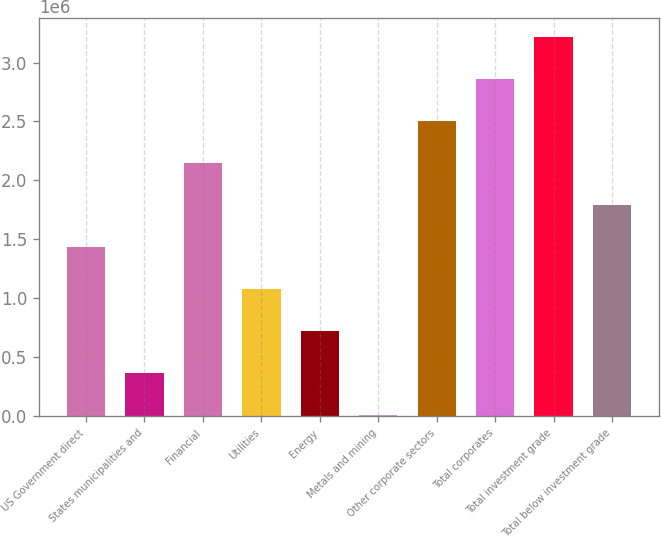Convert chart to OTSL. <chart><loc_0><loc_0><loc_500><loc_500><bar_chart><fcel>US Government direct<fcel>States municipalities and<fcel>Financial<fcel>Utilities<fcel>Energy<fcel>Metals and mining<fcel>Other corporate sectors<fcel>Total corporates<fcel>Total investment grade<fcel>Total below investment grade<nl><fcel>1.43742e+06<fcel>368149<fcel>2.15027e+06<fcel>1.081e+06<fcel>724574<fcel>11725<fcel>2.5067e+06<fcel>2.86312e+06<fcel>3.21954e+06<fcel>1.79385e+06<nl></chart> 